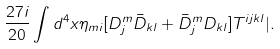Convert formula to latex. <formula><loc_0><loc_0><loc_500><loc_500>\frac { 2 7 i } { 2 0 } \int d ^ { 4 } x \eta _ { m i } [ D _ { j } ^ { m } \bar { D } _ { k l } + \bar { D } _ { j } ^ { m } D _ { k l } ] T ^ { i j k l } | .</formula> 